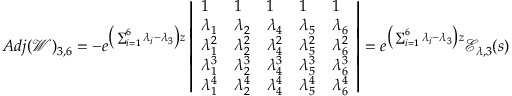Convert formula to latex. <formula><loc_0><loc_0><loc_500><loc_500>A d j ( \ m a t h s c r { W } ) _ { 3 , 6 } = - e ^ { \left ( \sum _ { i = 1 } ^ { 6 } \lambda _ { i } - \lambda _ { 3 } \right ) z } \left | \begin{array} { l l l l l } { 1 } & { 1 } & { 1 } & { 1 } & { 1 } \\ { \lambda _ { 1 } } & { \lambda _ { 2 } } & { \lambda _ { 4 } } & { \lambda _ { 5 } } & { \lambda _ { 6 } } \\ { \lambda _ { 1 } ^ { 2 } } & { \lambda _ { 2 } ^ { 2 } } & { \lambda _ { 4 } ^ { 2 } } & { \lambda _ { 5 } ^ { 2 } } & { \lambda _ { 6 } ^ { 2 } } \\ { \lambda _ { 1 } ^ { 3 } } & { \lambda _ { 2 } ^ { 3 } } & { \lambda _ { 4 } ^ { 3 } } & { \lambda _ { 5 } ^ { 3 } } & { \lambda _ { 6 } ^ { 3 } } \\ { \lambda _ { 1 } ^ { 4 } } & { \lambda _ { 2 } ^ { 4 } } & { \lambda _ { 4 } ^ { 4 } } & { \lambda _ { 5 } ^ { 4 } } & { \lambda _ { 6 } ^ { 4 } } \end{array} \right | = e ^ { \left ( \sum _ { i = 1 } ^ { 6 } \lambda _ { i } - \lambda _ { 3 } \right ) z } \ m a t h s c r { E } _ { \lambda , 3 } ( s )</formula> 